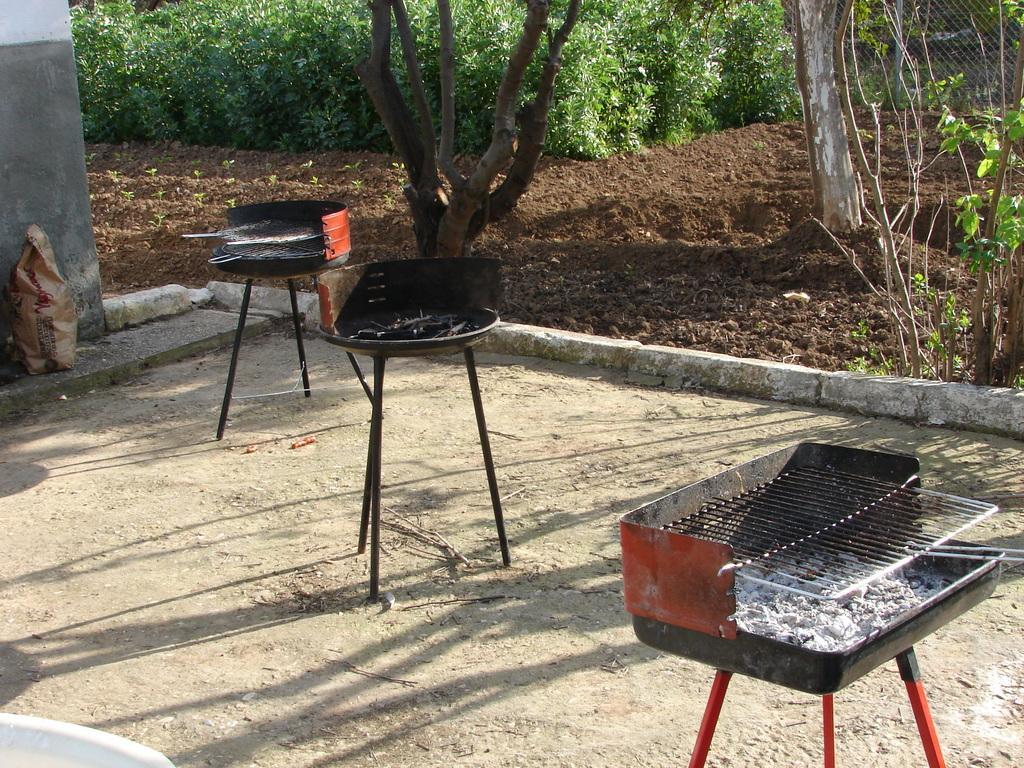How would you summarize this image in a sentence or two? In the picture there are three outdoor barbecue grill racks on the ground and behind them there is a soil surface, there are few trees and plants. 